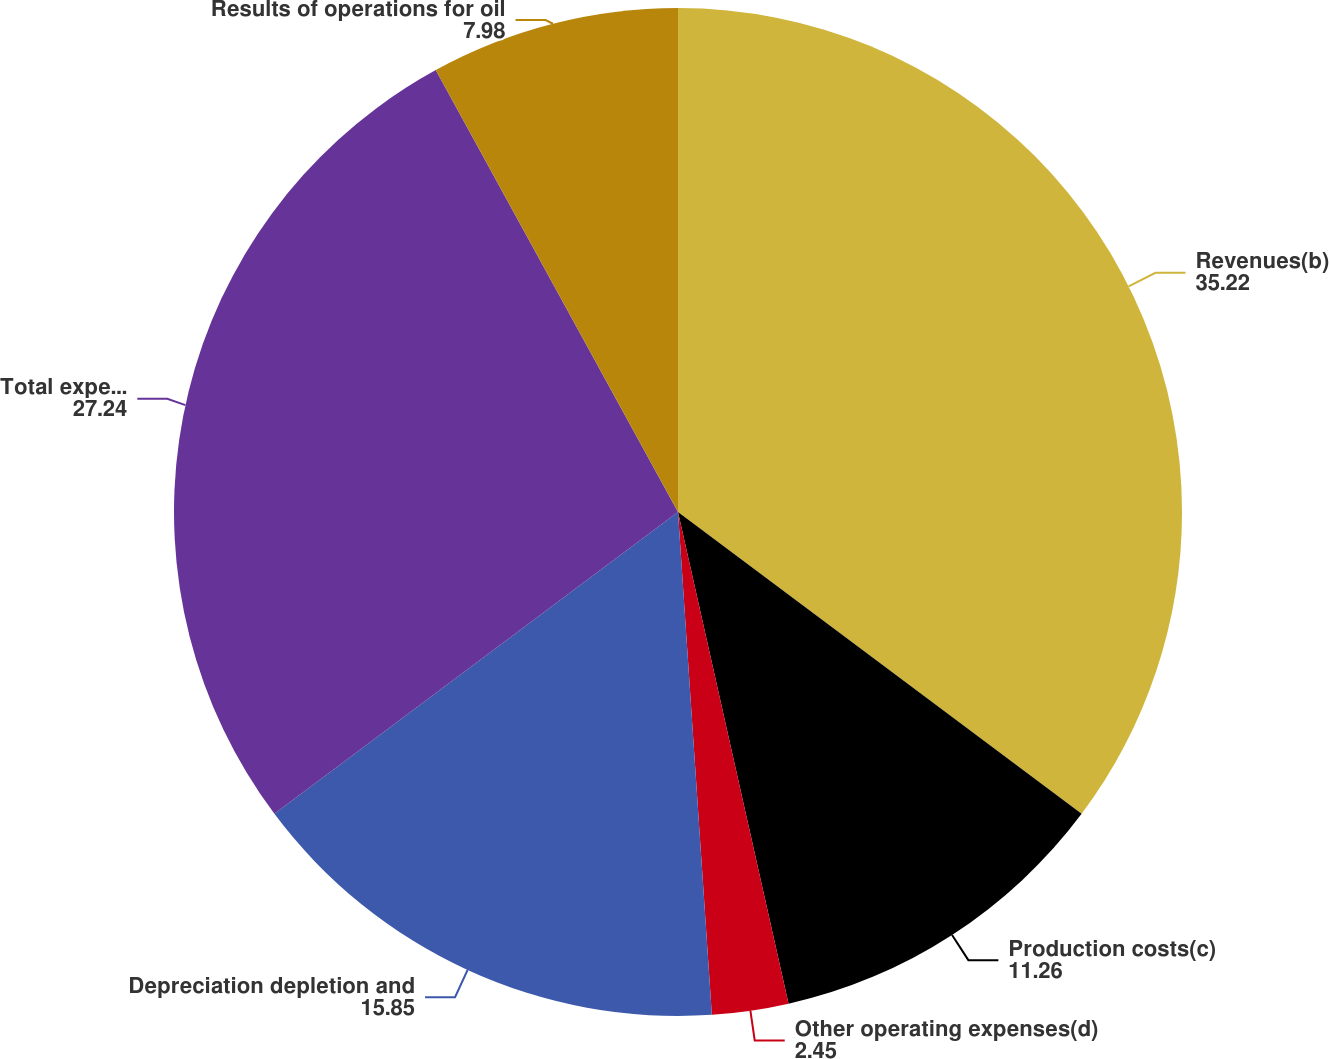Convert chart. <chart><loc_0><loc_0><loc_500><loc_500><pie_chart><fcel>Revenues(b)<fcel>Production costs(c)<fcel>Other operating expenses(d)<fcel>Depreciation depletion and<fcel>Total expenses<fcel>Results of operations for oil<nl><fcel>35.22%<fcel>11.26%<fcel>2.45%<fcel>15.85%<fcel>27.24%<fcel>7.98%<nl></chart> 